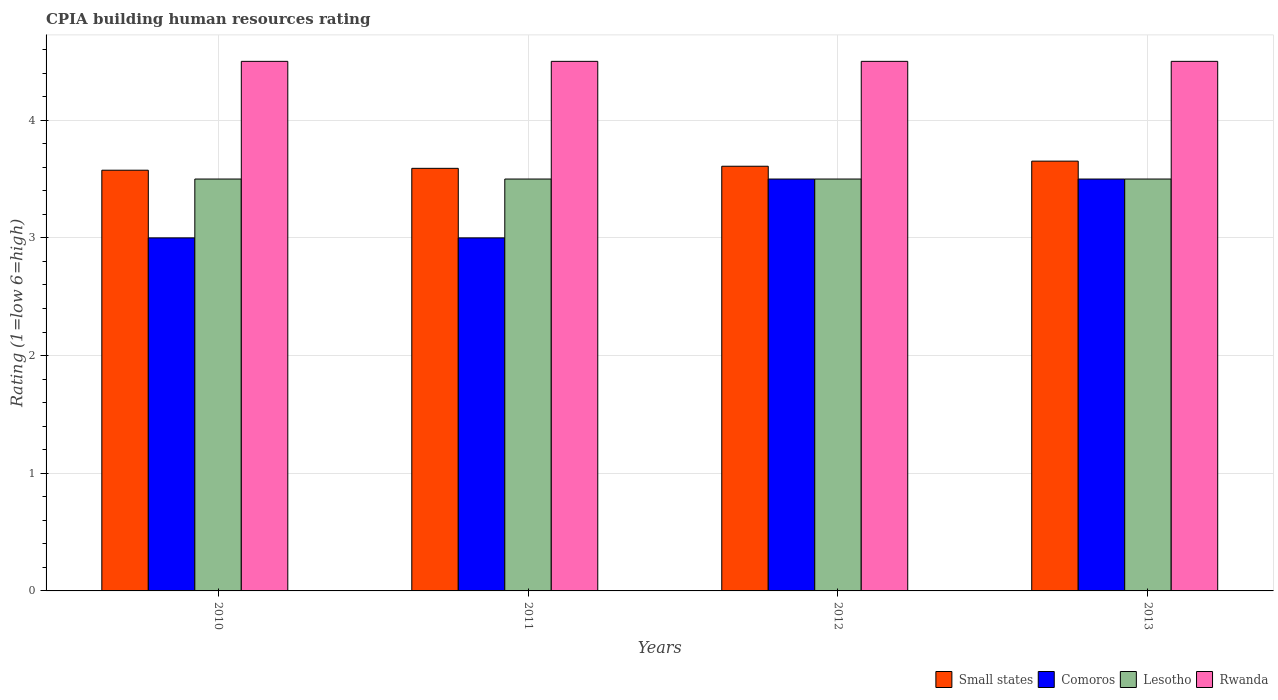How many groups of bars are there?
Make the answer very short. 4. How many bars are there on the 3rd tick from the left?
Keep it short and to the point. 4. What is the label of the 2nd group of bars from the left?
Your answer should be compact. 2011. What is the CPIA rating in Rwanda in 2013?
Ensure brevity in your answer.  4.5. Across all years, what is the maximum CPIA rating in Small states?
Your answer should be compact. 3.65. Across all years, what is the minimum CPIA rating in Small states?
Provide a succinct answer. 3.58. What is the total CPIA rating in Small states in the graph?
Your answer should be very brief. 14.43. What is the difference between the CPIA rating in Small states in 2010 and that in 2011?
Your response must be concise. -0.02. In the year 2013, what is the difference between the CPIA rating in Lesotho and CPIA rating in Rwanda?
Keep it short and to the point. -1. In how many years, is the CPIA rating in Comoros greater than 1.8?
Ensure brevity in your answer.  4. What is the ratio of the CPIA rating in Lesotho in 2010 to that in 2013?
Provide a succinct answer. 1. Is the difference between the CPIA rating in Lesotho in 2011 and 2012 greater than the difference between the CPIA rating in Rwanda in 2011 and 2012?
Give a very brief answer. No. Is it the case that in every year, the sum of the CPIA rating in Comoros and CPIA rating in Small states is greater than the sum of CPIA rating in Rwanda and CPIA rating in Lesotho?
Provide a succinct answer. No. What does the 2nd bar from the left in 2013 represents?
Your answer should be compact. Comoros. What does the 3rd bar from the right in 2010 represents?
Your answer should be very brief. Comoros. How many bars are there?
Give a very brief answer. 16. Are all the bars in the graph horizontal?
Your answer should be compact. No. How many years are there in the graph?
Make the answer very short. 4. Does the graph contain any zero values?
Provide a succinct answer. No. How are the legend labels stacked?
Offer a very short reply. Horizontal. What is the title of the graph?
Give a very brief answer. CPIA building human resources rating. Does "India" appear as one of the legend labels in the graph?
Your answer should be very brief. No. What is the label or title of the X-axis?
Offer a terse response. Years. What is the Rating (1=low 6=high) of Small states in 2010?
Offer a terse response. 3.58. What is the Rating (1=low 6=high) in Comoros in 2010?
Provide a succinct answer. 3. What is the Rating (1=low 6=high) of Lesotho in 2010?
Provide a succinct answer. 3.5. What is the Rating (1=low 6=high) in Rwanda in 2010?
Offer a very short reply. 4.5. What is the Rating (1=low 6=high) in Small states in 2011?
Provide a short and direct response. 3.59. What is the Rating (1=low 6=high) of Comoros in 2011?
Your answer should be very brief. 3. What is the Rating (1=low 6=high) of Lesotho in 2011?
Your response must be concise. 3.5. What is the Rating (1=low 6=high) of Small states in 2012?
Keep it short and to the point. 3.61. What is the Rating (1=low 6=high) of Comoros in 2012?
Offer a terse response. 3.5. What is the Rating (1=low 6=high) of Small states in 2013?
Ensure brevity in your answer.  3.65. What is the Rating (1=low 6=high) in Comoros in 2013?
Your response must be concise. 3.5. Across all years, what is the maximum Rating (1=low 6=high) of Small states?
Your answer should be very brief. 3.65. Across all years, what is the maximum Rating (1=low 6=high) of Comoros?
Your response must be concise. 3.5. Across all years, what is the maximum Rating (1=low 6=high) in Lesotho?
Offer a terse response. 3.5. Across all years, what is the minimum Rating (1=low 6=high) in Small states?
Give a very brief answer. 3.58. Across all years, what is the minimum Rating (1=low 6=high) of Comoros?
Ensure brevity in your answer.  3. Across all years, what is the minimum Rating (1=low 6=high) of Rwanda?
Make the answer very short. 4.5. What is the total Rating (1=low 6=high) of Small states in the graph?
Your answer should be very brief. 14.43. What is the total Rating (1=low 6=high) in Lesotho in the graph?
Keep it short and to the point. 14. What is the difference between the Rating (1=low 6=high) in Small states in 2010 and that in 2011?
Provide a succinct answer. -0.02. What is the difference between the Rating (1=low 6=high) of Comoros in 2010 and that in 2011?
Give a very brief answer. 0. What is the difference between the Rating (1=low 6=high) of Lesotho in 2010 and that in 2011?
Keep it short and to the point. 0. What is the difference between the Rating (1=low 6=high) of Rwanda in 2010 and that in 2011?
Your answer should be compact. 0. What is the difference between the Rating (1=low 6=high) in Small states in 2010 and that in 2012?
Make the answer very short. -0.03. What is the difference between the Rating (1=low 6=high) of Comoros in 2010 and that in 2012?
Provide a short and direct response. -0.5. What is the difference between the Rating (1=low 6=high) of Rwanda in 2010 and that in 2012?
Give a very brief answer. 0. What is the difference between the Rating (1=low 6=high) in Small states in 2010 and that in 2013?
Make the answer very short. -0.08. What is the difference between the Rating (1=low 6=high) in Comoros in 2010 and that in 2013?
Your response must be concise. -0.5. What is the difference between the Rating (1=low 6=high) of Rwanda in 2010 and that in 2013?
Your response must be concise. 0. What is the difference between the Rating (1=low 6=high) of Small states in 2011 and that in 2012?
Your response must be concise. -0.02. What is the difference between the Rating (1=low 6=high) of Comoros in 2011 and that in 2012?
Your response must be concise. -0.5. What is the difference between the Rating (1=low 6=high) in Lesotho in 2011 and that in 2012?
Offer a terse response. 0. What is the difference between the Rating (1=low 6=high) of Small states in 2011 and that in 2013?
Your response must be concise. -0.06. What is the difference between the Rating (1=low 6=high) in Rwanda in 2011 and that in 2013?
Provide a succinct answer. 0. What is the difference between the Rating (1=low 6=high) in Small states in 2012 and that in 2013?
Your response must be concise. -0.04. What is the difference between the Rating (1=low 6=high) of Comoros in 2012 and that in 2013?
Offer a very short reply. 0. What is the difference between the Rating (1=low 6=high) in Small states in 2010 and the Rating (1=low 6=high) in Comoros in 2011?
Give a very brief answer. 0.57. What is the difference between the Rating (1=low 6=high) in Small states in 2010 and the Rating (1=low 6=high) in Lesotho in 2011?
Ensure brevity in your answer.  0.07. What is the difference between the Rating (1=low 6=high) of Small states in 2010 and the Rating (1=low 6=high) of Rwanda in 2011?
Offer a terse response. -0.93. What is the difference between the Rating (1=low 6=high) of Comoros in 2010 and the Rating (1=low 6=high) of Lesotho in 2011?
Ensure brevity in your answer.  -0.5. What is the difference between the Rating (1=low 6=high) of Lesotho in 2010 and the Rating (1=low 6=high) of Rwanda in 2011?
Keep it short and to the point. -1. What is the difference between the Rating (1=low 6=high) of Small states in 2010 and the Rating (1=low 6=high) of Comoros in 2012?
Provide a short and direct response. 0.07. What is the difference between the Rating (1=low 6=high) in Small states in 2010 and the Rating (1=low 6=high) in Lesotho in 2012?
Provide a short and direct response. 0.07. What is the difference between the Rating (1=low 6=high) of Small states in 2010 and the Rating (1=low 6=high) of Rwanda in 2012?
Make the answer very short. -0.93. What is the difference between the Rating (1=low 6=high) in Comoros in 2010 and the Rating (1=low 6=high) in Rwanda in 2012?
Make the answer very short. -1.5. What is the difference between the Rating (1=low 6=high) of Lesotho in 2010 and the Rating (1=low 6=high) of Rwanda in 2012?
Keep it short and to the point. -1. What is the difference between the Rating (1=low 6=high) in Small states in 2010 and the Rating (1=low 6=high) in Comoros in 2013?
Keep it short and to the point. 0.07. What is the difference between the Rating (1=low 6=high) of Small states in 2010 and the Rating (1=low 6=high) of Lesotho in 2013?
Your answer should be compact. 0.07. What is the difference between the Rating (1=low 6=high) in Small states in 2010 and the Rating (1=low 6=high) in Rwanda in 2013?
Provide a succinct answer. -0.93. What is the difference between the Rating (1=low 6=high) in Comoros in 2010 and the Rating (1=low 6=high) in Rwanda in 2013?
Your answer should be compact. -1.5. What is the difference between the Rating (1=low 6=high) of Lesotho in 2010 and the Rating (1=low 6=high) of Rwanda in 2013?
Provide a short and direct response. -1. What is the difference between the Rating (1=low 6=high) in Small states in 2011 and the Rating (1=low 6=high) in Comoros in 2012?
Make the answer very short. 0.09. What is the difference between the Rating (1=low 6=high) in Small states in 2011 and the Rating (1=low 6=high) in Lesotho in 2012?
Offer a terse response. 0.09. What is the difference between the Rating (1=low 6=high) of Small states in 2011 and the Rating (1=low 6=high) of Rwanda in 2012?
Provide a succinct answer. -0.91. What is the difference between the Rating (1=low 6=high) of Small states in 2011 and the Rating (1=low 6=high) of Comoros in 2013?
Your answer should be compact. 0.09. What is the difference between the Rating (1=low 6=high) of Small states in 2011 and the Rating (1=low 6=high) of Lesotho in 2013?
Give a very brief answer. 0.09. What is the difference between the Rating (1=low 6=high) of Small states in 2011 and the Rating (1=low 6=high) of Rwanda in 2013?
Make the answer very short. -0.91. What is the difference between the Rating (1=low 6=high) of Lesotho in 2011 and the Rating (1=low 6=high) of Rwanda in 2013?
Provide a succinct answer. -1. What is the difference between the Rating (1=low 6=high) in Small states in 2012 and the Rating (1=low 6=high) in Comoros in 2013?
Provide a succinct answer. 0.11. What is the difference between the Rating (1=low 6=high) in Small states in 2012 and the Rating (1=low 6=high) in Lesotho in 2013?
Offer a terse response. 0.11. What is the difference between the Rating (1=low 6=high) of Small states in 2012 and the Rating (1=low 6=high) of Rwanda in 2013?
Your answer should be very brief. -0.89. What is the difference between the Rating (1=low 6=high) in Comoros in 2012 and the Rating (1=low 6=high) in Lesotho in 2013?
Keep it short and to the point. 0. What is the difference between the Rating (1=low 6=high) of Comoros in 2012 and the Rating (1=low 6=high) of Rwanda in 2013?
Offer a terse response. -1. What is the average Rating (1=low 6=high) in Small states per year?
Your answer should be very brief. 3.61. What is the average Rating (1=low 6=high) in Lesotho per year?
Keep it short and to the point. 3.5. In the year 2010, what is the difference between the Rating (1=low 6=high) in Small states and Rating (1=low 6=high) in Comoros?
Provide a succinct answer. 0.57. In the year 2010, what is the difference between the Rating (1=low 6=high) of Small states and Rating (1=low 6=high) of Lesotho?
Provide a short and direct response. 0.07. In the year 2010, what is the difference between the Rating (1=low 6=high) of Small states and Rating (1=low 6=high) of Rwanda?
Your answer should be very brief. -0.93. In the year 2010, what is the difference between the Rating (1=low 6=high) in Comoros and Rating (1=low 6=high) in Lesotho?
Ensure brevity in your answer.  -0.5. In the year 2010, what is the difference between the Rating (1=low 6=high) in Lesotho and Rating (1=low 6=high) in Rwanda?
Provide a succinct answer. -1. In the year 2011, what is the difference between the Rating (1=low 6=high) of Small states and Rating (1=low 6=high) of Comoros?
Give a very brief answer. 0.59. In the year 2011, what is the difference between the Rating (1=low 6=high) of Small states and Rating (1=low 6=high) of Lesotho?
Provide a succinct answer. 0.09. In the year 2011, what is the difference between the Rating (1=low 6=high) of Small states and Rating (1=low 6=high) of Rwanda?
Your answer should be very brief. -0.91. In the year 2011, what is the difference between the Rating (1=low 6=high) in Comoros and Rating (1=low 6=high) in Lesotho?
Ensure brevity in your answer.  -0.5. In the year 2011, what is the difference between the Rating (1=low 6=high) of Comoros and Rating (1=low 6=high) of Rwanda?
Offer a terse response. -1.5. In the year 2012, what is the difference between the Rating (1=low 6=high) of Small states and Rating (1=low 6=high) of Comoros?
Give a very brief answer. 0.11. In the year 2012, what is the difference between the Rating (1=low 6=high) of Small states and Rating (1=low 6=high) of Lesotho?
Provide a short and direct response. 0.11. In the year 2012, what is the difference between the Rating (1=low 6=high) in Small states and Rating (1=low 6=high) in Rwanda?
Offer a very short reply. -0.89. In the year 2012, what is the difference between the Rating (1=low 6=high) of Comoros and Rating (1=low 6=high) of Rwanda?
Make the answer very short. -1. In the year 2012, what is the difference between the Rating (1=low 6=high) in Lesotho and Rating (1=low 6=high) in Rwanda?
Your answer should be very brief. -1. In the year 2013, what is the difference between the Rating (1=low 6=high) of Small states and Rating (1=low 6=high) of Comoros?
Make the answer very short. 0.15. In the year 2013, what is the difference between the Rating (1=low 6=high) in Small states and Rating (1=low 6=high) in Lesotho?
Your response must be concise. 0.15. In the year 2013, what is the difference between the Rating (1=low 6=high) of Small states and Rating (1=low 6=high) of Rwanda?
Offer a very short reply. -0.85. In the year 2013, what is the difference between the Rating (1=low 6=high) in Comoros and Rating (1=low 6=high) in Lesotho?
Offer a terse response. 0. What is the ratio of the Rating (1=low 6=high) in Comoros in 2010 to that in 2011?
Keep it short and to the point. 1. What is the ratio of the Rating (1=low 6=high) of Rwanda in 2010 to that in 2011?
Your response must be concise. 1. What is the ratio of the Rating (1=low 6=high) of Small states in 2010 to that in 2012?
Keep it short and to the point. 0.99. What is the ratio of the Rating (1=low 6=high) of Lesotho in 2010 to that in 2012?
Give a very brief answer. 1. What is the ratio of the Rating (1=low 6=high) in Small states in 2010 to that in 2013?
Offer a terse response. 0.98. What is the ratio of the Rating (1=low 6=high) of Lesotho in 2010 to that in 2013?
Provide a succinct answer. 1. What is the ratio of the Rating (1=low 6=high) of Rwanda in 2010 to that in 2013?
Your response must be concise. 1. What is the ratio of the Rating (1=low 6=high) of Comoros in 2011 to that in 2012?
Your answer should be compact. 0.86. What is the ratio of the Rating (1=low 6=high) of Small states in 2011 to that in 2013?
Provide a short and direct response. 0.98. What is the ratio of the Rating (1=low 6=high) of Comoros in 2011 to that in 2013?
Provide a short and direct response. 0.86. What is the ratio of the Rating (1=low 6=high) in Lesotho in 2011 to that in 2013?
Offer a very short reply. 1. What is the ratio of the Rating (1=low 6=high) of Small states in 2012 to that in 2013?
Make the answer very short. 0.99. What is the ratio of the Rating (1=low 6=high) of Comoros in 2012 to that in 2013?
Give a very brief answer. 1. What is the difference between the highest and the second highest Rating (1=low 6=high) in Small states?
Provide a succinct answer. 0.04. What is the difference between the highest and the second highest Rating (1=low 6=high) of Lesotho?
Ensure brevity in your answer.  0. What is the difference between the highest and the lowest Rating (1=low 6=high) in Small states?
Ensure brevity in your answer.  0.08. What is the difference between the highest and the lowest Rating (1=low 6=high) in Lesotho?
Offer a very short reply. 0. What is the difference between the highest and the lowest Rating (1=low 6=high) of Rwanda?
Make the answer very short. 0. 